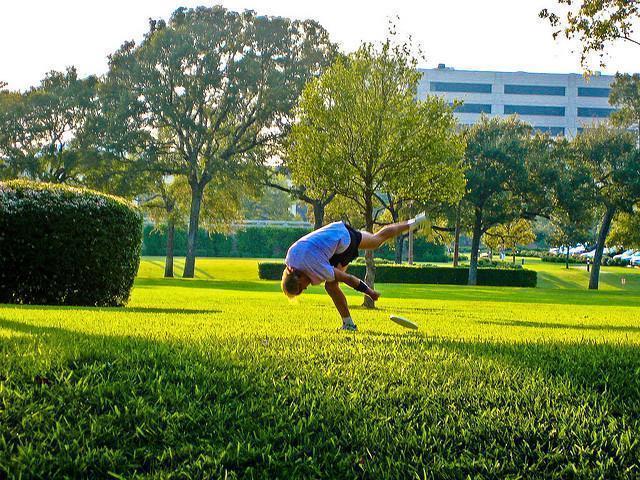What is the possible danger faced by the man?
Answer the question by selecting the correct answer among the 4 following choices.
Options: Concussion, broken hip, broken backbone, broken wrist. Concussion. 